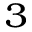<formula> <loc_0><loc_0><loc_500><loc_500>^ { 3 }</formula> 